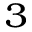<formula> <loc_0><loc_0><loc_500><loc_500>^ { 3 }</formula> 